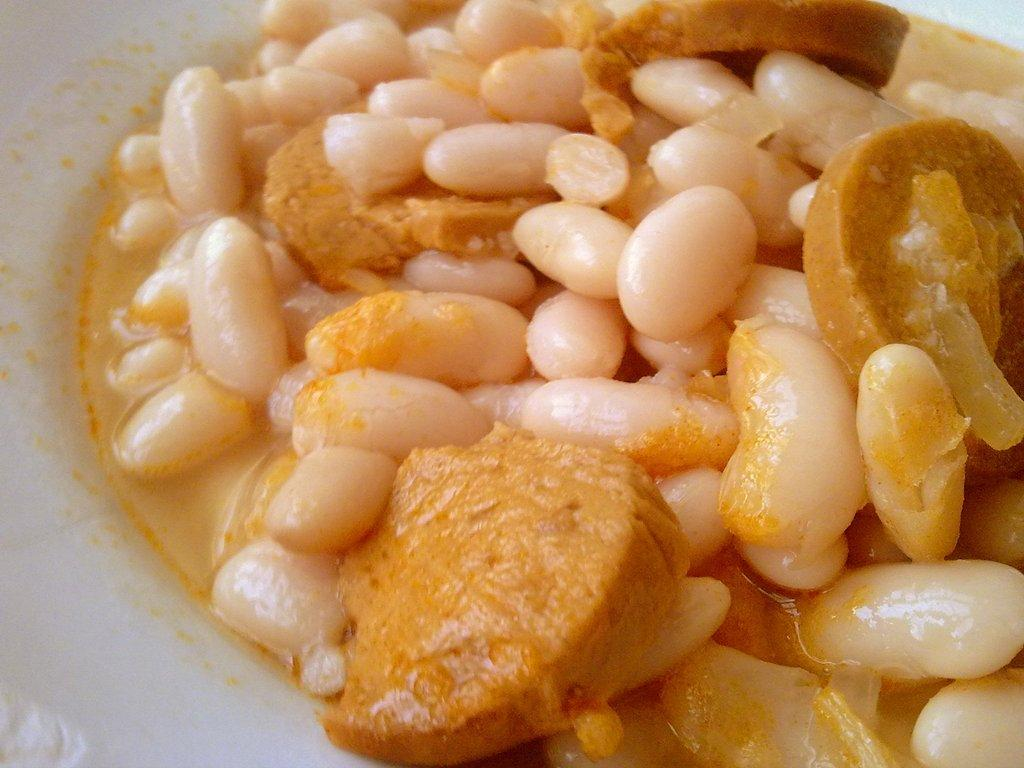What is on the plate in the image? There is food on a plate in the image. How many centimeters long is the arm in the image? There is no arm present in the image; it only features a plate of food. 